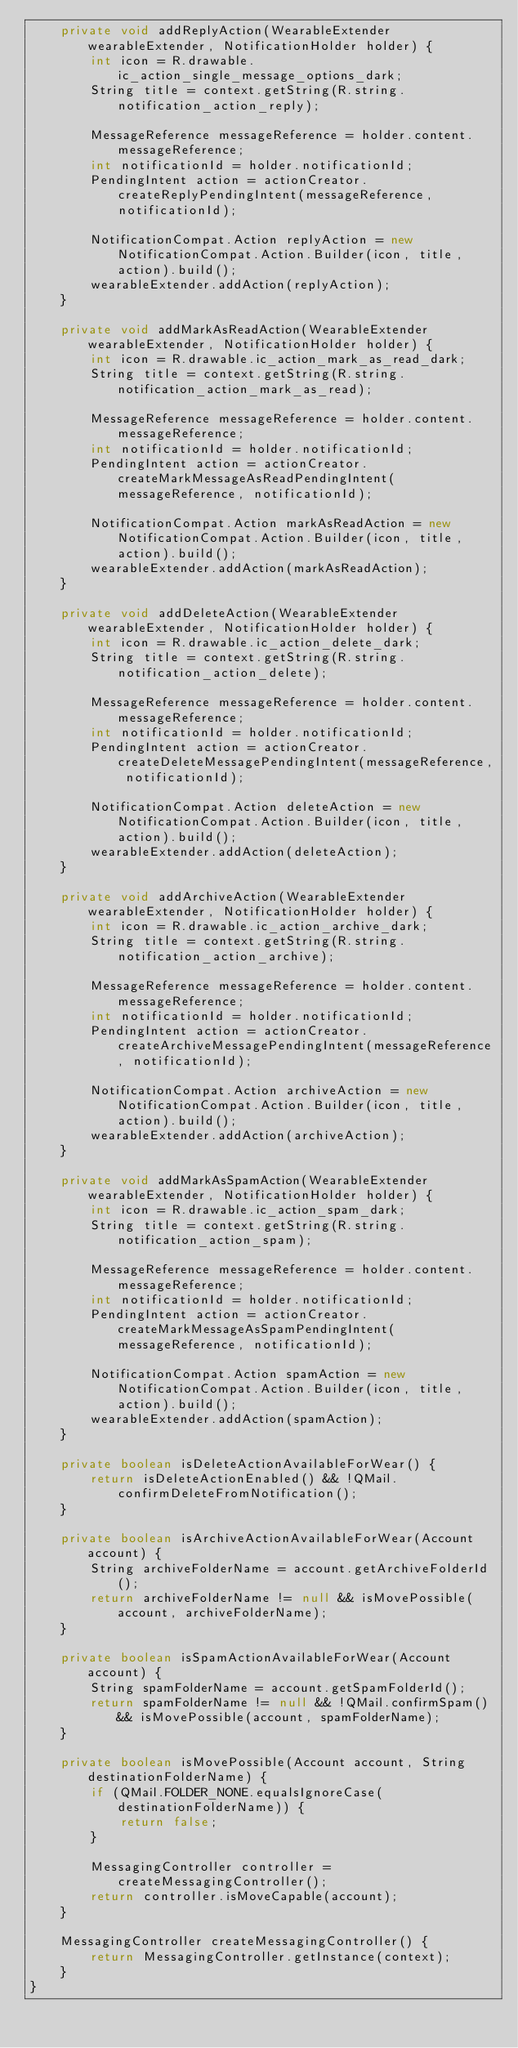Convert code to text. <code><loc_0><loc_0><loc_500><loc_500><_Java_>    private void addReplyAction(WearableExtender wearableExtender, NotificationHolder holder) {
        int icon = R.drawable.ic_action_single_message_options_dark;
        String title = context.getString(R.string.notification_action_reply);

        MessageReference messageReference = holder.content.messageReference;
        int notificationId = holder.notificationId;
        PendingIntent action = actionCreator.createReplyPendingIntent(messageReference, notificationId);

        NotificationCompat.Action replyAction = new NotificationCompat.Action.Builder(icon, title, action).build();
        wearableExtender.addAction(replyAction);
    }

    private void addMarkAsReadAction(WearableExtender wearableExtender, NotificationHolder holder) {
        int icon = R.drawable.ic_action_mark_as_read_dark;
        String title = context.getString(R.string.notification_action_mark_as_read);

        MessageReference messageReference = holder.content.messageReference;
        int notificationId = holder.notificationId;
        PendingIntent action = actionCreator.createMarkMessageAsReadPendingIntent(messageReference, notificationId);

        NotificationCompat.Action markAsReadAction = new NotificationCompat.Action.Builder(icon, title, action).build();
        wearableExtender.addAction(markAsReadAction);
    }

    private void addDeleteAction(WearableExtender wearableExtender, NotificationHolder holder) {
        int icon = R.drawable.ic_action_delete_dark;
        String title = context.getString(R.string.notification_action_delete);

        MessageReference messageReference = holder.content.messageReference;
        int notificationId = holder.notificationId;
        PendingIntent action = actionCreator.createDeleteMessagePendingIntent(messageReference, notificationId);

        NotificationCompat.Action deleteAction = new NotificationCompat.Action.Builder(icon, title, action).build();
        wearableExtender.addAction(deleteAction);
    }

    private void addArchiveAction(WearableExtender wearableExtender, NotificationHolder holder) {
        int icon = R.drawable.ic_action_archive_dark;
        String title = context.getString(R.string.notification_action_archive);

        MessageReference messageReference = holder.content.messageReference;
        int notificationId = holder.notificationId;
        PendingIntent action = actionCreator.createArchiveMessagePendingIntent(messageReference, notificationId);

        NotificationCompat.Action archiveAction = new NotificationCompat.Action.Builder(icon, title, action).build();
        wearableExtender.addAction(archiveAction);
    }

    private void addMarkAsSpamAction(WearableExtender wearableExtender, NotificationHolder holder) {
        int icon = R.drawable.ic_action_spam_dark;
        String title = context.getString(R.string.notification_action_spam);

        MessageReference messageReference = holder.content.messageReference;
        int notificationId = holder.notificationId;
        PendingIntent action = actionCreator.createMarkMessageAsSpamPendingIntent(messageReference, notificationId);

        NotificationCompat.Action spamAction = new NotificationCompat.Action.Builder(icon, title, action).build();
        wearableExtender.addAction(spamAction);
    }

    private boolean isDeleteActionAvailableForWear() {
        return isDeleteActionEnabled() && !QMail.confirmDeleteFromNotification();
    }

    private boolean isArchiveActionAvailableForWear(Account account) {
        String archiveFolderName = account.getArchiveFolderId();
        return archiveFolderName != null && isMovePossible(account, archiveFolderName);
    }

    private boolean isSpamActionAvailableForWear(Account account) {
        String spamFolderName = account.getSpamFolderId();
        return spamFolderName != null && !QMail.confirmSpam() && isMovePossible(account, spamFolderName);
    }

    private boolean isMovePossible(Account account, String destinationFolderName) {
        if (QMail.FOLDER_NONE.equalsIgnoreCase(destinationFolderName)) {
            return false;
        }

        MessagingController controller = createMessagingController();
        return controller.isMoveCapable(account);
    }

    MessagingController createMessagingController() {
        return MessagingController.getInstance(context);
    }
}
</code> 